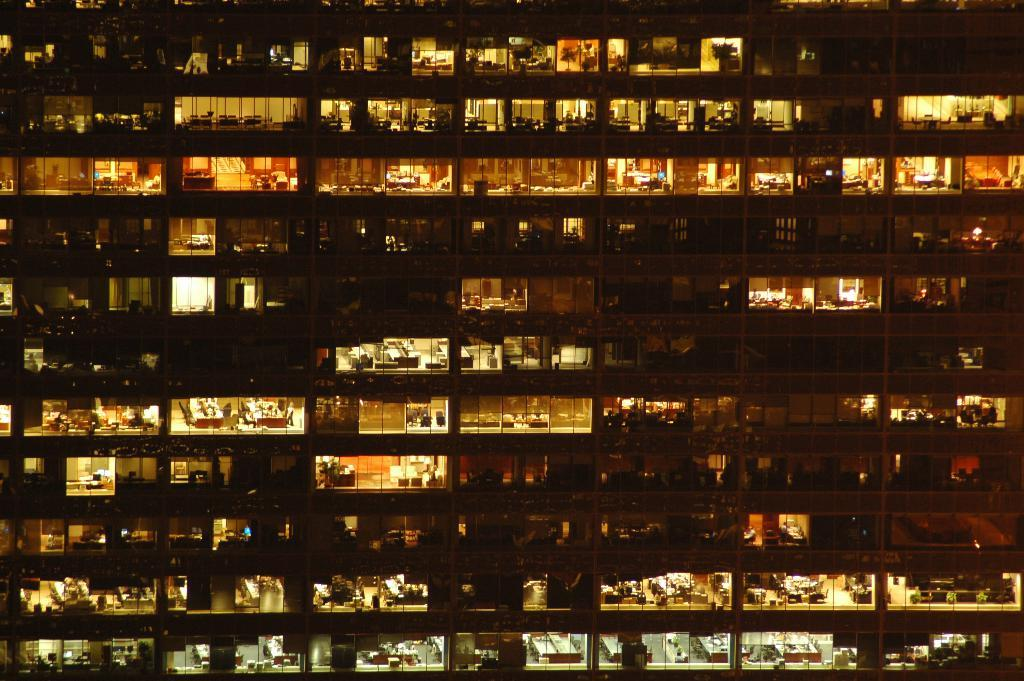What type of structure is visible in the image? There is a building in the image. How many feet are visible on the island in the image? There is no island or feet present in the image; it only features a building. What type of journey is depicted in the image? There is no journey depicted in the image; it only features a building. 